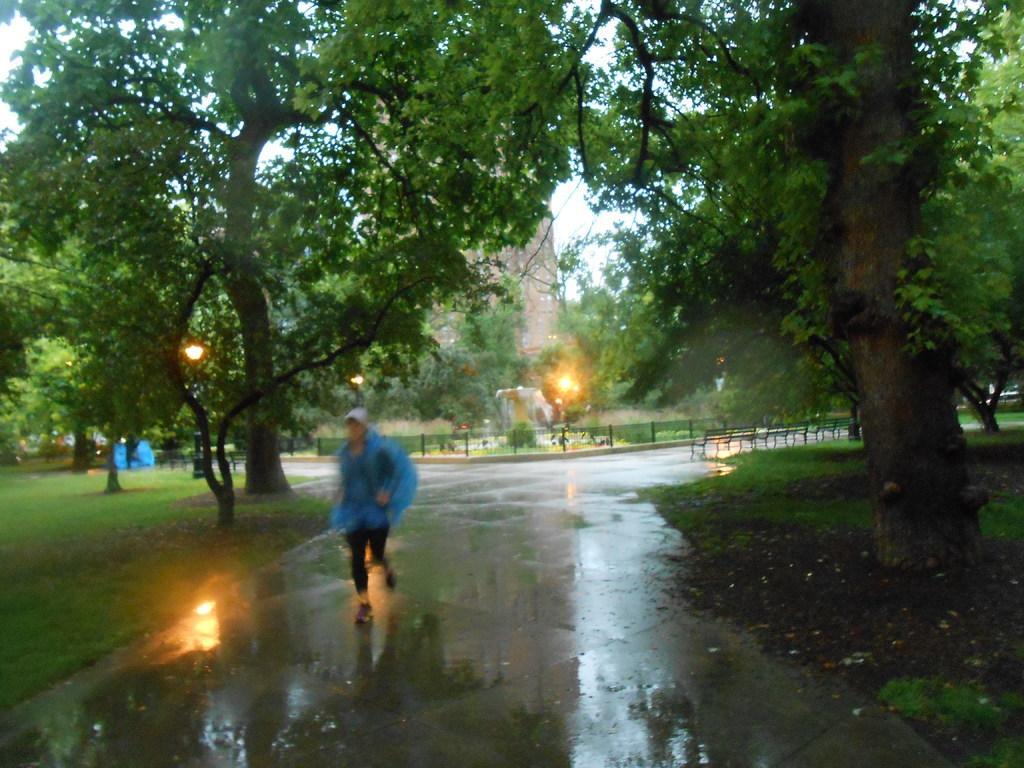In one or two sentences, can you explain what this image depicts? In this image I can see a path in the centre and on it I can see one person. I can see this person is wearing a cap, a blue colour coat, black pant and shoes. On the both sides of the path I can see grass ground, number of trees and in the background I can see few lights, few benches, a building and the sky. 